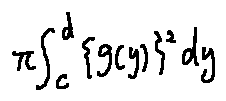Convert formula to latex. <formula><loc_0><loc_0><loc_500><loc_500>\pi \int \lim i t s _ { c } ^ { d } \{ g ( y ) \} ^ { 2 } d y</formula> 